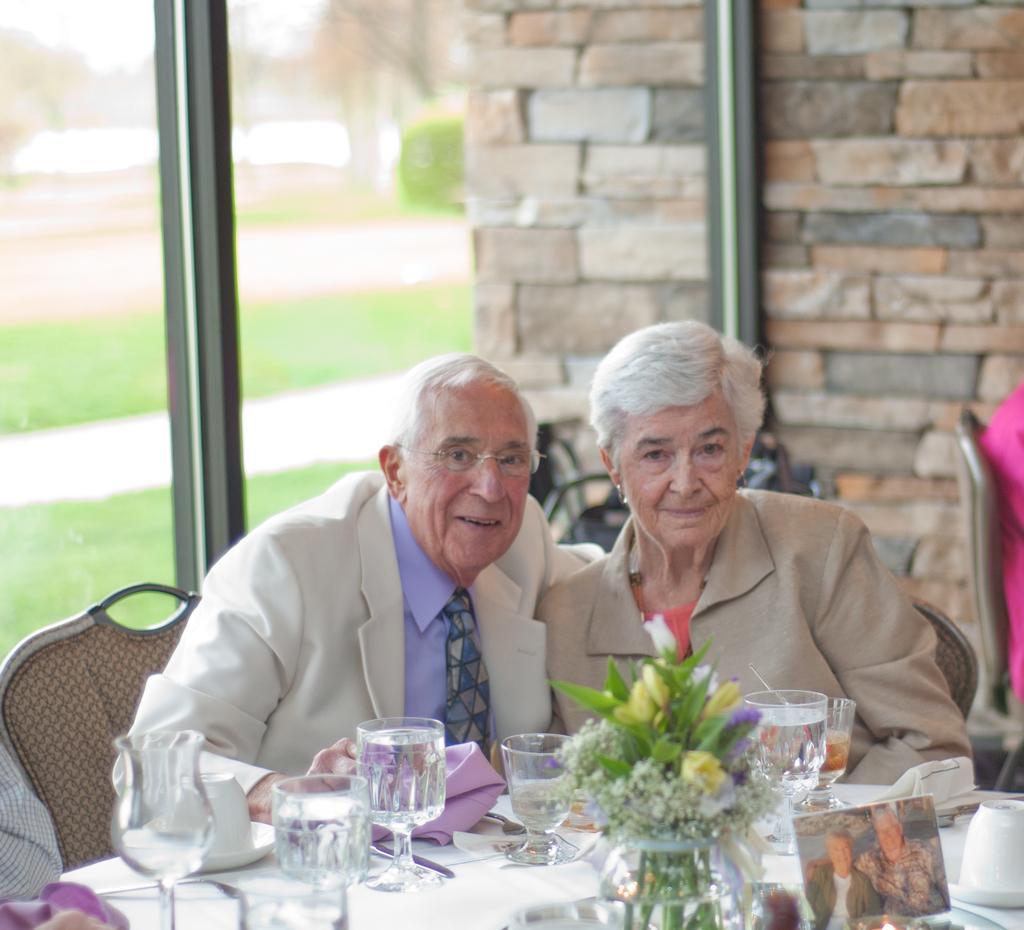Please provide a concise description of this image. One old man and an old woman are sitting on the chairs and in front of them there is table full of glasses and napkins and a flower vase, behind them there is a glass window and a wall made of bricks. 